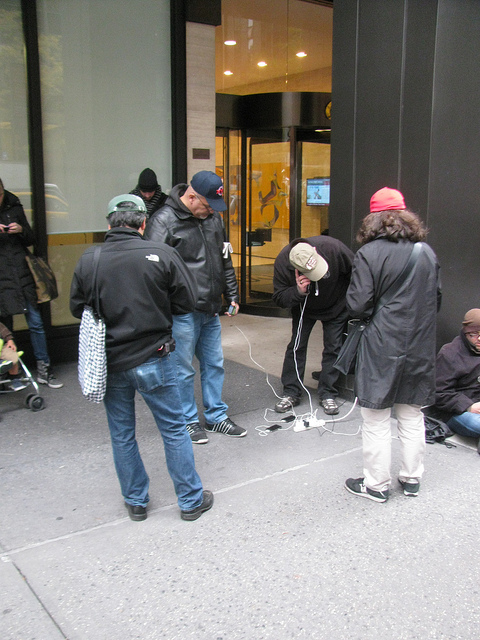<image>Where is the bench? There is no bench in the image. Where is the bench? There is no bench in the image. 